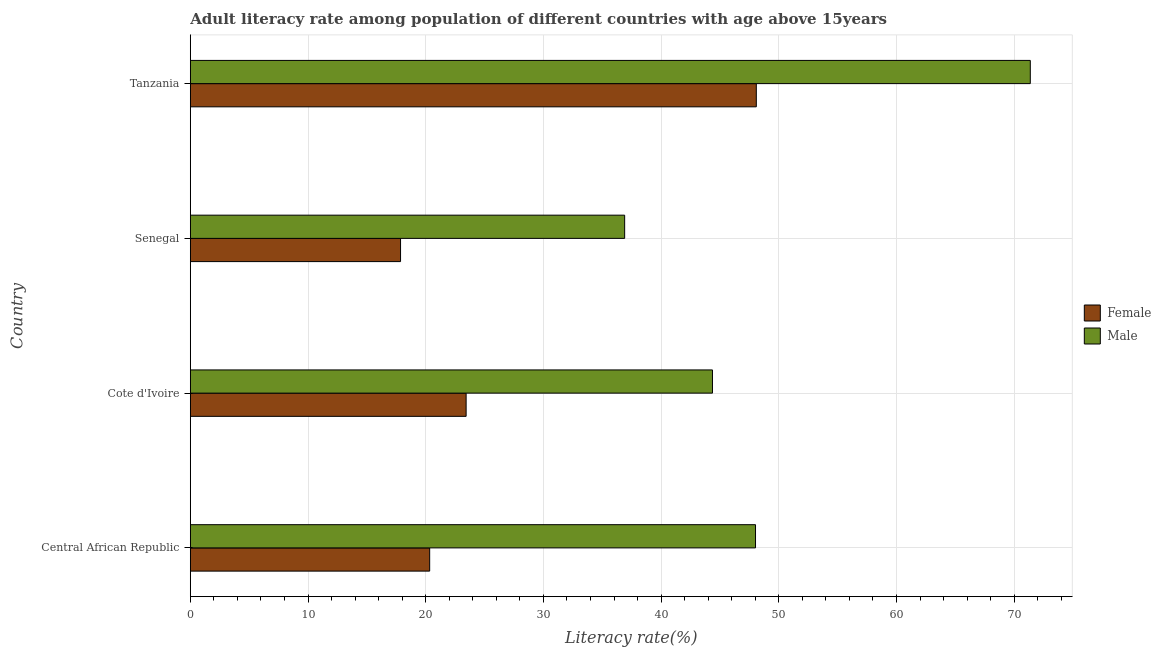How many groups of bars are there?
Your response must be concise. 4. Are the number of bars per tick equal to the number of legend labels?
Your response must be concise. Yes. Are the number of bars on each tick of the Y-axis equal?
Give a very brief answer. Yes. How many bars are there on the 1st tick from the top?
Give a very brief answer. 2. How many bars are there on the 2nd tick from the bottom?
Your answer should be compact. 2. What is the label of the 3rd group of bars from the top?
Give a very brief answer. Cote d'Ivoire. What is the male adult literacy rate in Cote d'Ivoire?
Your response must be concise. 44.36. Across all countries, what is the maximum male adult literacy rate?
Offer a very short reply. 71.37. Across all countries, what is the minimum female adult literacy rate?
Offer a very short reply. 17.86. In which country was the male adult literacy rate maximum?
Your answer should be compact. Tanzania. In which country was the female adult literacy rate minimum?
Provide a short and direct response. Senegal. What is the total male adult literacy rate in the graph?
Provide a short and direct response. 200.65. What is the difference between the male adult literacy rate in Cote d'Ivoire and that in Tanzania?
Offer a terse response. -27. What is the difference between the male adult literacy rate in Cote d'Ivoire and the female adult literacy rate in Senegal?
Your answer should be very brief. 26.5. What is the average female adult literacy rate per country?
Provide a short and direct response. 27.43. What is the difference between the male adult literacy rate and female adult literacy rate in Tanzania?
Offer a very short reply. 23.28. In how many countries, is the female adult literacy rate greater than 6 %?
Provide a succinct answer. 4. What is the ratio of the female adult literacy rate in Central African Republic to that in Cote d'Ivoire?
Ensure brevity in your answer.  0.87. Is the male adult literacy rate in Senegal less than that in Tanzania?
Your answer should be compact. Yes. What is the difference between the highest and the second highest male adult literacy rate?
Provide a short and direct response. 23.34. What is the difference between the highest and the lowest female adult literacy rate?
Your response must be concise. 30.22. Is the sum of the male adult literacy rate in Central African Republic and Senegal greater than the maximum female adult literacy rate across all countries?
Make the answer very short. Yes. What does the 1st bar from the bottom in Cote d'Ivoire represents?
Ensure brevity in your answer.  Female. How many bars are there?
Offer a terse response. 8. Are all the bars in the graph horizontal?
Your answer should be very brief. Yes. How many countries are there in the graph?
Your response must be concise. 4. What is the difference between two consecutive major ticks on the X-axis?
Provide a succinct answer. 10. Are the values on the major ticks of X-axis written in scientific E-notation?
Your answer should be very brief. No. Does the graph contain grids?
Give a very brief answer. Yes. How are the legend labels stacked?
Make the answer very short. Vertical. What is the title of the graph?
Offer a very short reply. Adult literacy rate among population of different countries with age above 15years. Does "Banks" appear as one of the legend labels in the graph?
Offer a very short reply. No. What is the label or title of the X-axis?
Offer a very short reply. Literacy rate(%). What is the Literacy rate(%) in Female in Central African Republic?
Your answer should be very brief. 20.34. What is the Literacy rate(%) in Male in Central African Republic?
Keep it short and to the point. 48.02. What is the Literacy rate(%) in Female in Cote d'Ivoire?
Ensure brevity in your answer.  23.43. What is the Literacy rate(%) of Male in Cote d'Ivoire?
Offer a very short reply. 44.36. What is the Literacy rate(%) in Female in Senegal?
Provide a short and direct response. 17.86. What is the Literacy rate(%) of Male in Senegal?
Ensure brevity in your answer.  36.9. What is the Literacy rate(%) in Female in Tanzania?
Give a very brief answer. 48.09. What is the Literacy rate(%) in Male in Tanzania?
Ensure brevity in your answer.  71.37. Across all countries, what is the maximum Literacy rate(%) in Female?
Offer a very short reply. 48.09. Across all countries, what is the maximum Literacy rate(%) of Male?
Provide a succinct answer. 71.37. Across all countries, what is the minimum Literacy rate(%) of Female?
Provide a short and direct response. 17.86. Across all countries, what is the minimum Literacy rate(%) in Male?
Provide a short and direct response. 36.9. What is the total Literacy rate(%) of Female in the graph?
Your response must be concise. 109.72. What is the total Literacy rate(%) of Male in the graph?
Provide a succinct answer. 200.65. What is the difference between the Literacy rate(%) in Female in Central African Republic and that in Cote d'Ivoire?
Ensure brevity in your answer.  -3.1. What is the difference between the Literacy rate(%) in Male in Central African Republic and that in Cote d'Ivoire?
Keep it short and to the point. 3.66. What is the difference between the Literacy rate(%) in Female in Central African Republic and that in Senegal?
Ensure brevity in your answer.  2.47. What is the difference between the Literacy rate(%) of Male in Central African Republic and that in Senegal?
Provide a succinct answer. 11.12. What is the difference between the Literacy rate(%) of Female in Central African Republic and that in Tanzania?
Keep it short and to the point. -27.75. What is the difference between the Literacy rate(%) in Male in Central African Republic and that in Tanzania?
Keep it short and to the point. -23.35. What is the difference between the Literacy rate(%) of Female in Cote d'Ivoire and that in Senegal?
Give a very brief answer. 5.57. What is the difference between the Literacy rate(%) of Male in Cote d'Ivoire and that in Senegal?
Give a very brief answer. 7.46. What is the difference between the Literacy rate(%) in Female in Cote d'Ivoire and that in Tanzania?
Your answer should be very brief. -24.65. What is the difference between the Literacy rate(%) of Male in Cote d'Ivoire and that in Tanzania?
Ensure brevity in your answer.  -27. What is the difference between the Literacy rate(%) of Female in Senegal and that in Tanzania?
Your answer should be very brief. -30.22. What is the difference between the Literacy rate(%) in Male in Senegal and that in Tanzania?
Your answer should be compact. -34.46. What is the difference between the Literacy rate(%) of Female in Central African Republic and the Literacy rate(%) of Male in Cote d'Ivoire?
Give a very brief answer. -24.03. What is the difference between the Literacy rate(%) of Female in Central African Republic and the Literacy rate(%) of Male in Senegal?
Ensure brevity in your answer.  -16.57. What is the difference between the Literacy rate(%) of Female in Central African Republic and the Literacy rate(%) of Male in Tanzania?
Ensure brevity in your answer.  -51.03. What is the difference between the Literacy rate(%) in Female in Cote d'Ivoire and the Literacy rate(%) in Male in Senegal?
Keep it short and to the point. -13.47. What is the difference between the Literacy rate(%) in Female in Cote d'Ivoire and the Literacy rate(%) in Male in Tanzania?
Give a very brief answer. -47.93. What is the difference between the Literacy rate(%) in Female in Senegal and the Literacy rate(%) in Male in Tanzania?
Your answer should be very brief. -53.5. What is the average Literacy rate(%) in Female per country?
Provide a short and direct response. 27.43. What is the average Literacy rate(%) in Male per country?
Provide a succinct answer. 50.16. What is the difference between the Literacy rate(%) of Female and Literacy rate(%) of Male in Central African Republic?
Your answer should be compact. -27.68. What is the difference between the Literacy rate(%) of Female and Literacy rate(%) of Male in Cote d'Ivoire?
Provide a succinct answer. -20.93. What is the difference between the Literacy rate(%) of Female and Literacy rate(%) of Male in Senegal?
Provide a succinct answer. -19.04. What is the difference between the Literacy rate(%) in Female and Literacy rate(%) in Male in Tanzania?
Offer a very short reply. -23.28. What is the ratio of the Literacy rate(%) of Female in Central African Republic to that in Cote d'Ivoire?
Your answer should be compact. 0.87. What is the ratio of the Literacy rate(%) in Male in Central African Republic to that in Cote d'Ivoire?
Offer a terse response. 1.08. What is the ratio of the Literacy rate(%) in Female in Central African Republic to that in Senegal?
Give a very brief answer. 1.14. What is the ratio of the Literacy rate(%) in Male in Central African Republic to that in Senegal?
Provide a succinct answer. 1.3. What is the ratio of the Literacy rate(%) in Female in Central African Republic to that in Tanzania?
Give a very brief answer. 0.42. What is the ratio of the Literacy rate(%) in Male in Central African Republic to that in Tanzania?
Provide a short and direct response. 0.67. What is the ratio of the Literacy rate(%) in Female in Cote d'Ivoire to that in Senegal?
Your answer should be very brief. 1.31. What is the ratio of the Literacy rate(%) in Male in Cote d'Ivoire to that in Senegal?
Your answer should be very brief. 1.2. What is the ratio of the Literacy rate(%) of Female in Cote d'Ivoire to that in Tanzania?
Offer a terse response. 0.49. What is the ratio of the Literacy rate(%) of Male in Cote d'Ivoire to that in Tanzania?
Make the answer very short. 0.62. What is the ratio of the Literacy rate(%) in Female in Senegal to that in Tanzania?
Your answer should be very brief. 0.37. What is the ratio of the Literacy rate(%) in Male in Senegal to that in Tanzania?
Your answer should be very brief. 0.52. What is the difference between the highest and the second highest Literacy rate(%) in Female?
Provide a succinct answer. 24.65. What is the difference between the highest and the second highest Literacy rate(%) of Male?
Make the answer very short. 23.35. What is the difference between the highest and the lowest Literacy rate(%) in Female?
Ensure brevity in your answer.  30.22. What is the difference between the highest and the lowest Literacy rate(%) in Male?
Your answer should be very brief. 34.46. 